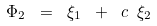<formula> <loc_0><loc_0><loc_500><loc_500>\Phi _ { 2 } \ = \ \xi _ { 1 } \ + \ c \ \xi _ { 2 }</formula> 